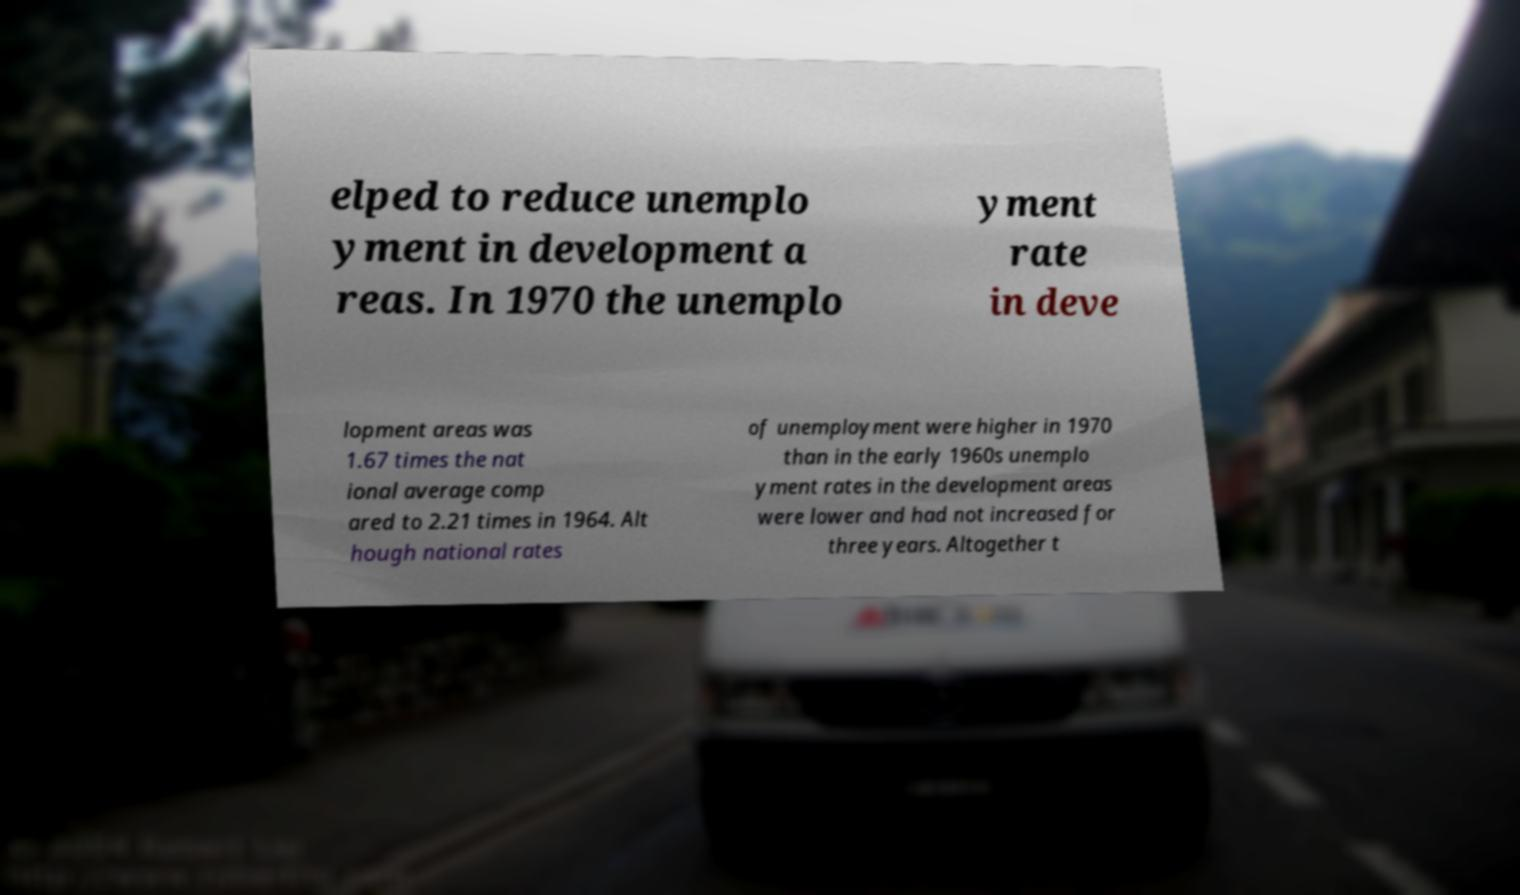For documentation purposes, I need the text within this image transcribed. Could you provide that? elped to reduce unemplo yment in development a reas. In 1970 the unemplo yment rate in deve lopment areas was 1.67 times the nat ional average comp ared to 2.21 times in 1964. Alt hough national rates of unemployment were higher in 1970 than in the early 1960s unemplo yment rates in the development areas were lower and had not increased for three years. Altogether t 